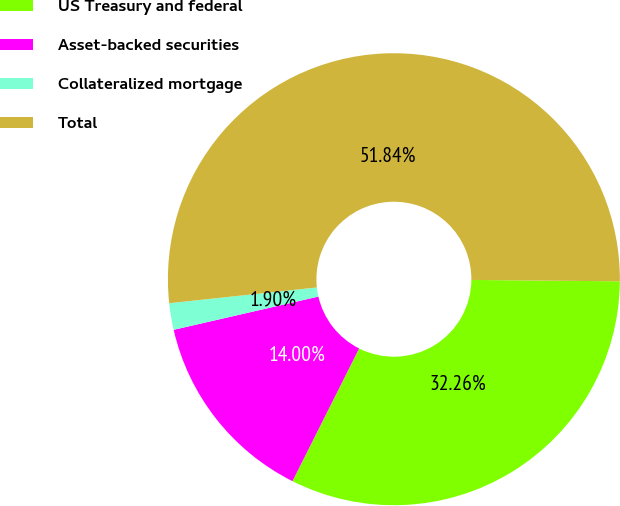Convert chart to OTSL. <chart><loc_0><loc_0><loc_500><loc_500><pie_chart><fcel>US Treasury and federal<fcel>Asset-backed securities<fcel>Collateralized mortgage<fcel>Total<nl><fcel>32.26%<fcel>14.0%<fcel>1.9%<fcel>51.84%<nl></chart> 